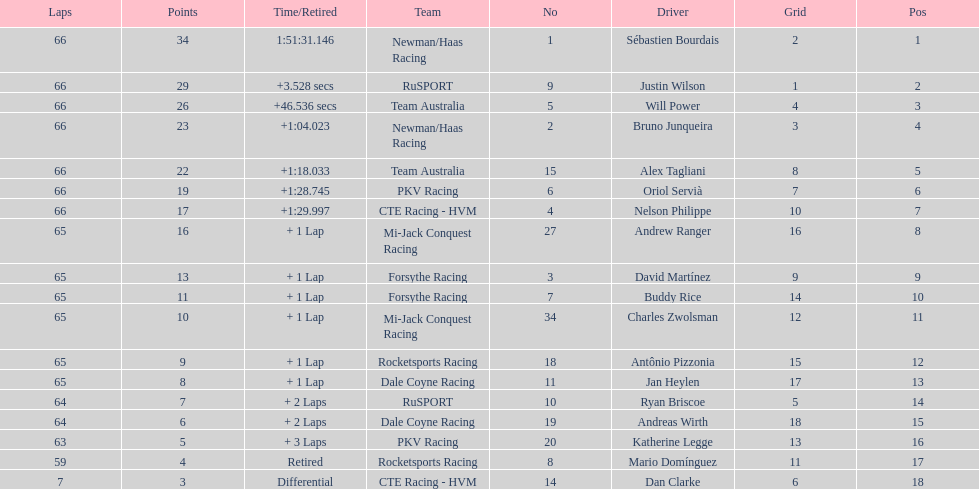Which country is represented by the most drivers? United Kingdom. 